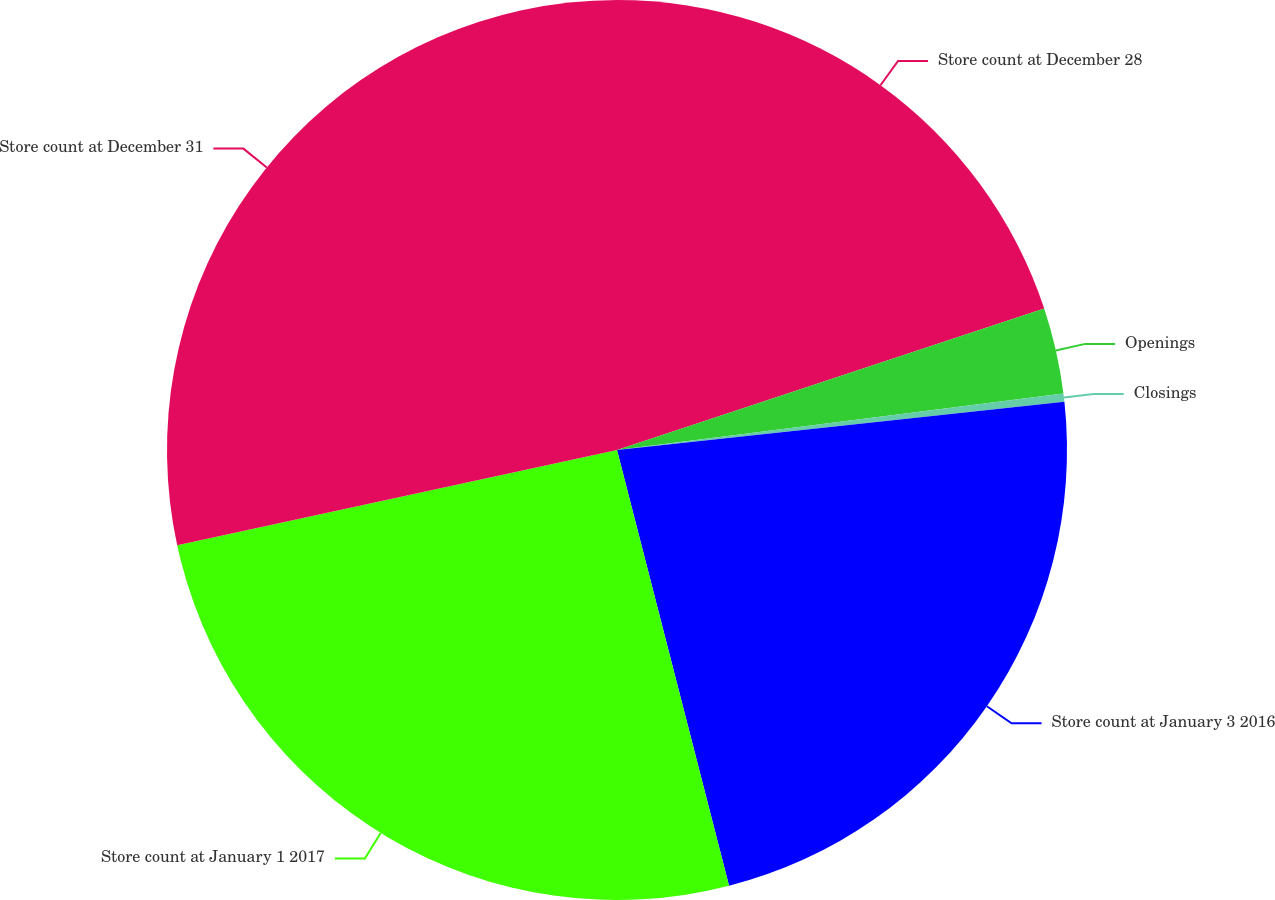<chart> <loc_0><loc_0><loc_500><loc_500><pie_chart><fcel>Store count at December 28<fcel>Openings<fcel>Closings<fcel>Store count at January 3 2016<fcel>Store count at January 1 2017<fcel>Store count at December 31<nl><fcel>19.91%<fcel>3.08%<fcel>0.3%<fcel>22.7%<fcel>25.61%<fcel>28.39%<nl></chart> 